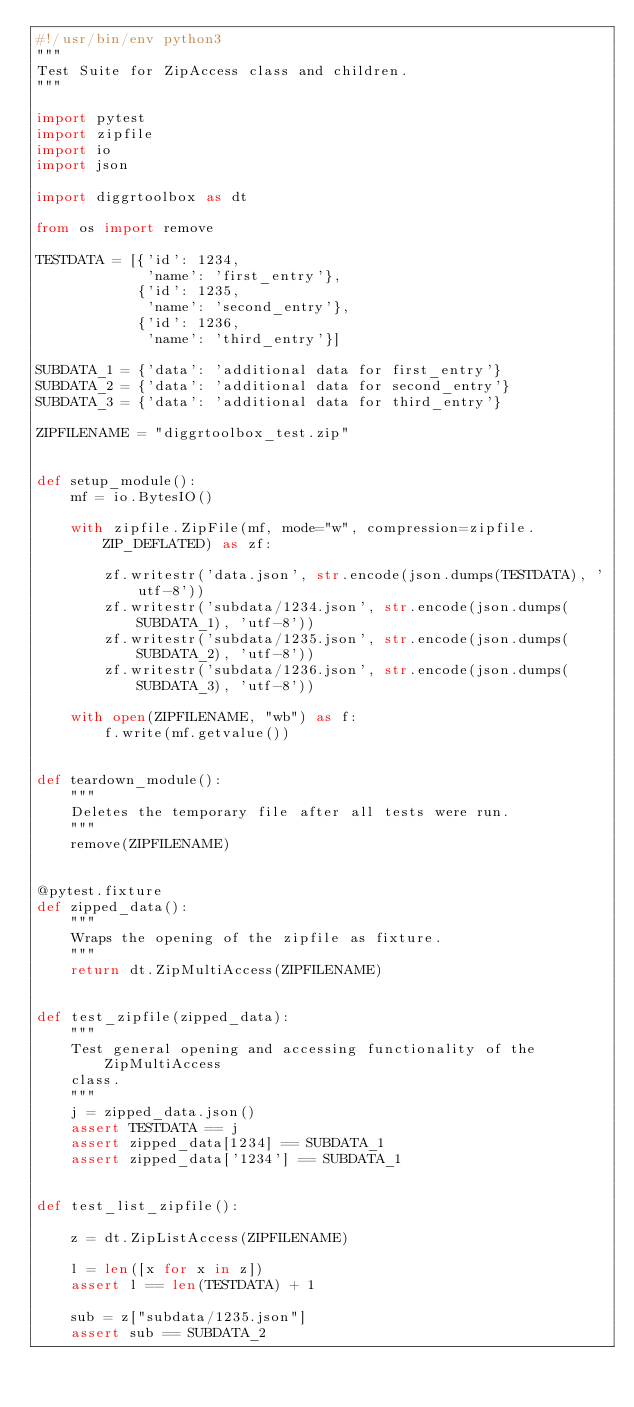Convert code to text. <code><loc_0><loc_0><loc_500><loc_500><_Python_>#!/usr/bin/env python3
"""
Test Suite for ZipAccess class and children.
"""

import pytest
import zipfile
import io
import json

import diggrtoolbox as dt

from os import remove

TESTDATA = [{'id': 1234,
             'name': 'first_entry'},
            {'id': 1235,
             'name': 'second_entry'},
            {'id': 1236,
             'name': 'third_entry'}]

SUBDATA_1 = {'data': 'additional data for first_entry'}
SUBDATA_2 = {'data': 'additional data for second_entry'}
SUBDATA_3 = {'data': 'additional data for third_entry'}

ZIPFILENAME = "diggrtoolbox_test.zip"


def setup_module():
    mf = io.BytesIO()

    with zipfile.ZipFile(mf, mode="w", compression=zipfile.ZIP_DEFLATED) as zf:

        zf.writestr('data.json', str.encode(json.dumps(TESTDATA), 'utf-8'))
        zf.writestr('subdata/1234.json', str.encode(json.dumps(SUBDATA_1), 'utf-8'))
        zf.writestr('subdata/1235.json', str.encode(json.dumps(SUBDATA_2), 'utf-8'))
        zf.writestr('subdata/1236.json', str.encode(json.dumps(SUBDATA_3), 'utf-8'))

    with open(ZIPFILENAME, "wb") as f:
        f.write(mf.getvalue())


def teardown_module():
    """
    Deletes the temporary file after all tests were run.
    """
    remove(ZIPFILENAME)


@pytest.fixture
def zipped_data():
    """
    Wraps the opening of the zipfile as fixture.
    """
    return dt.ZipMultiAccess(ZIPFILENAME)


def test_zipfile(zipped_data):
    """
    Test general opening and accessing functionality of the ZipMultiAccess
    class.
    """
    j = zipped_data.json()
    assert TESTDATA == j
    assert zipped_data[1234] == SUBDATA_1
    assert zipped_data['1234'] == SUBDATA_1


def test_list_zipfile():

    z = dt.ZipListAccess(ZIPFILENAME)
    
    l = len([x for x in z])
    assert l == len(TESTDATA) + 1

    sub = z["subdata/1235.json"]
    assert sub == SUBDATA_2
</code> 